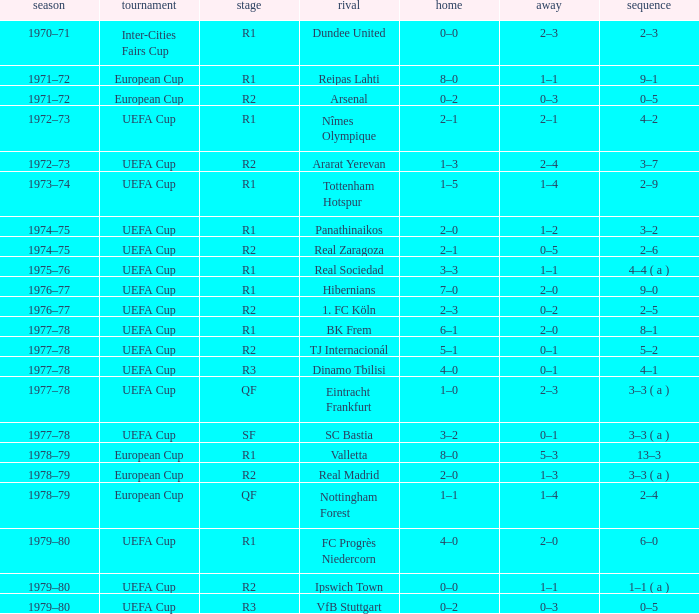Which Home has a Competition of european cup, and a Round of qf? 1–1. 